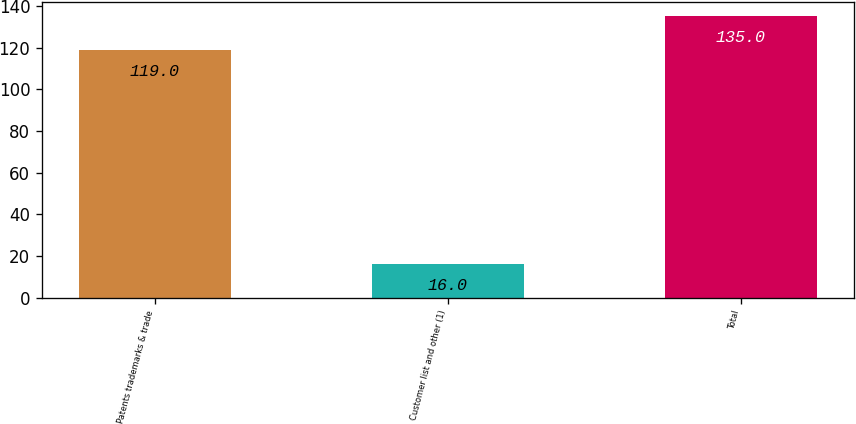<chart> <loc_0><loc_0><loc_500><loc_500><bar_chart><fcel>Patents trademarks & trade<fcel>Customer list and other (1)<fcel>Total<nl><fcel>119<fcel>16<fcel>135<nl></chart> 